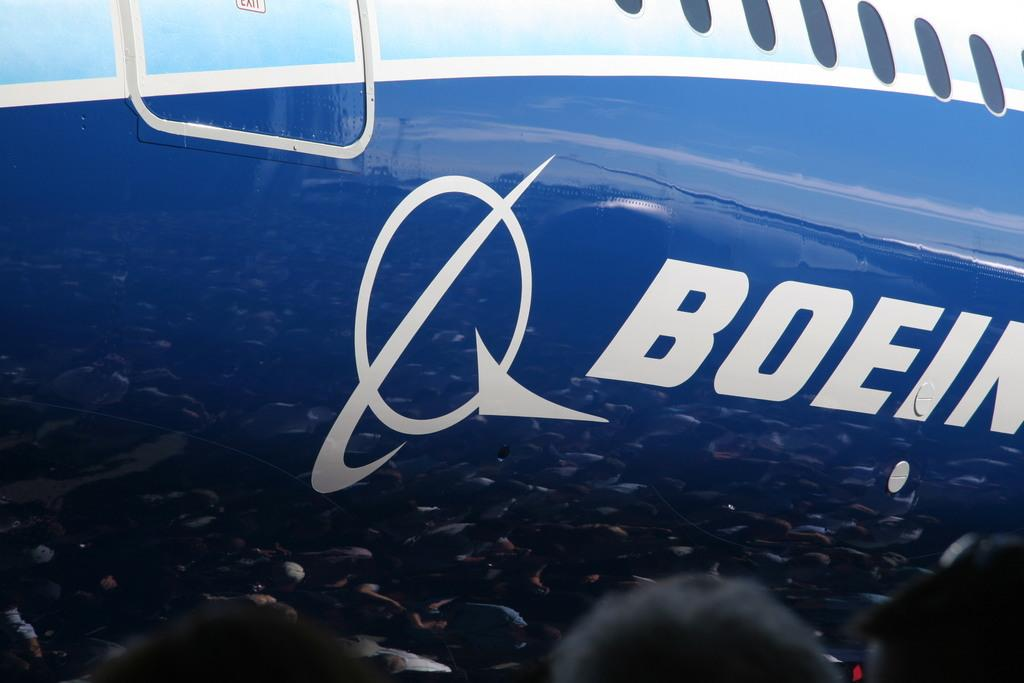<image>
Offer a succinct explanation of the picture presented. A plane painted with two shades of blue has the letters BOEIN in white. 